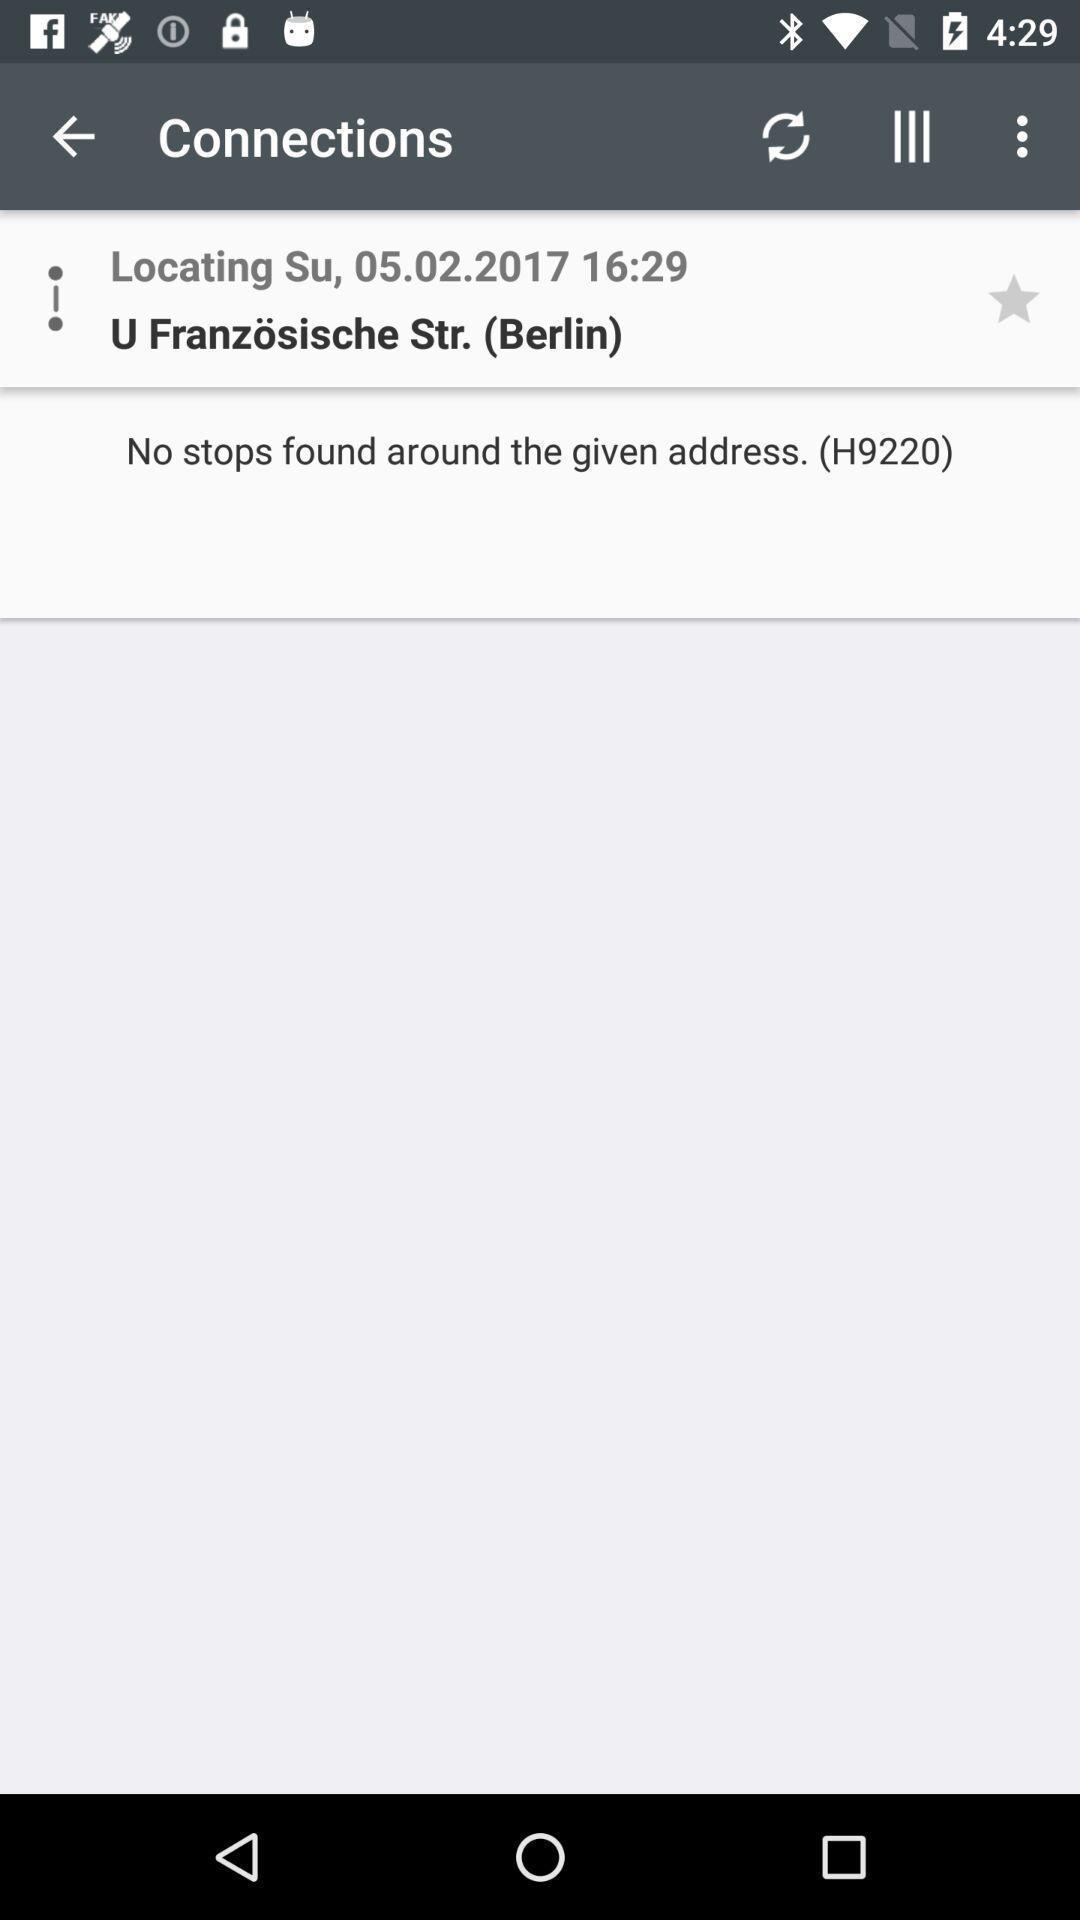Tell me what you see in this picture. Page showing location in connection menu. 